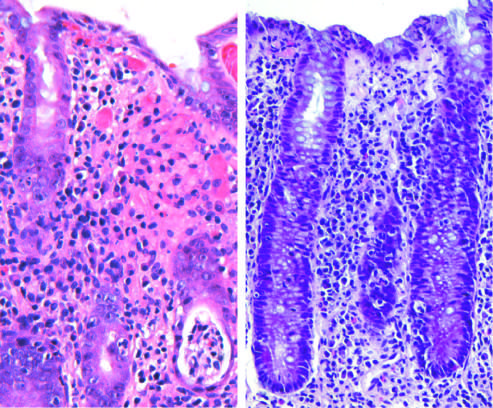does campylobacter jejuni infection produce acute, self-limited colitis?
Answer the question using a single word or phrase. Yes 